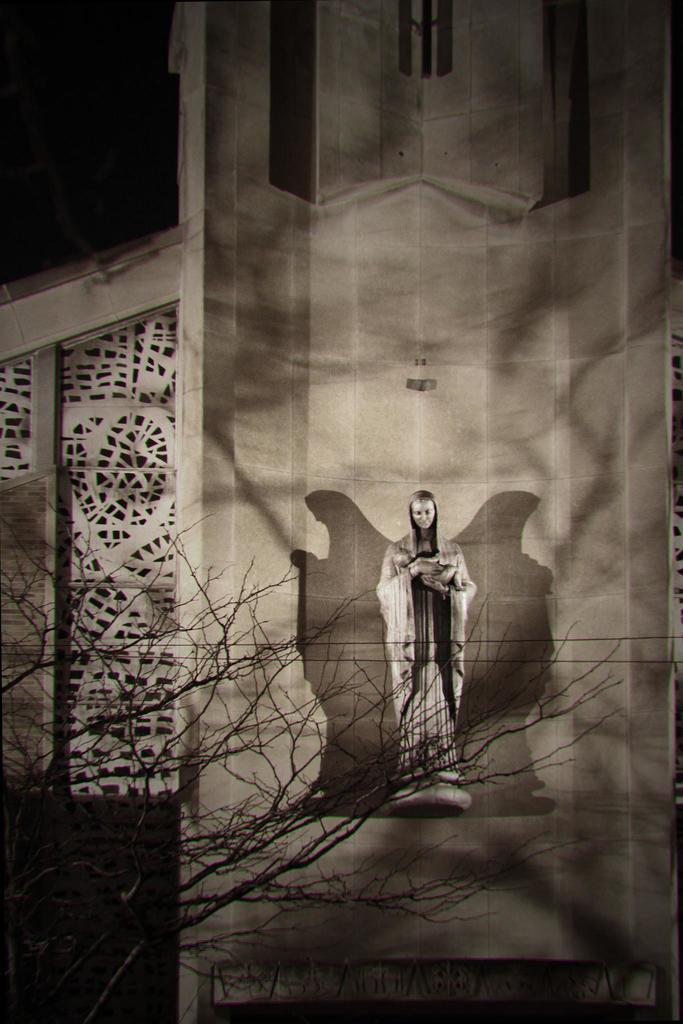Please provide a concise description of this image. There is a building and a sculpture is attached to the building and there is a dry tree in front of the building. 